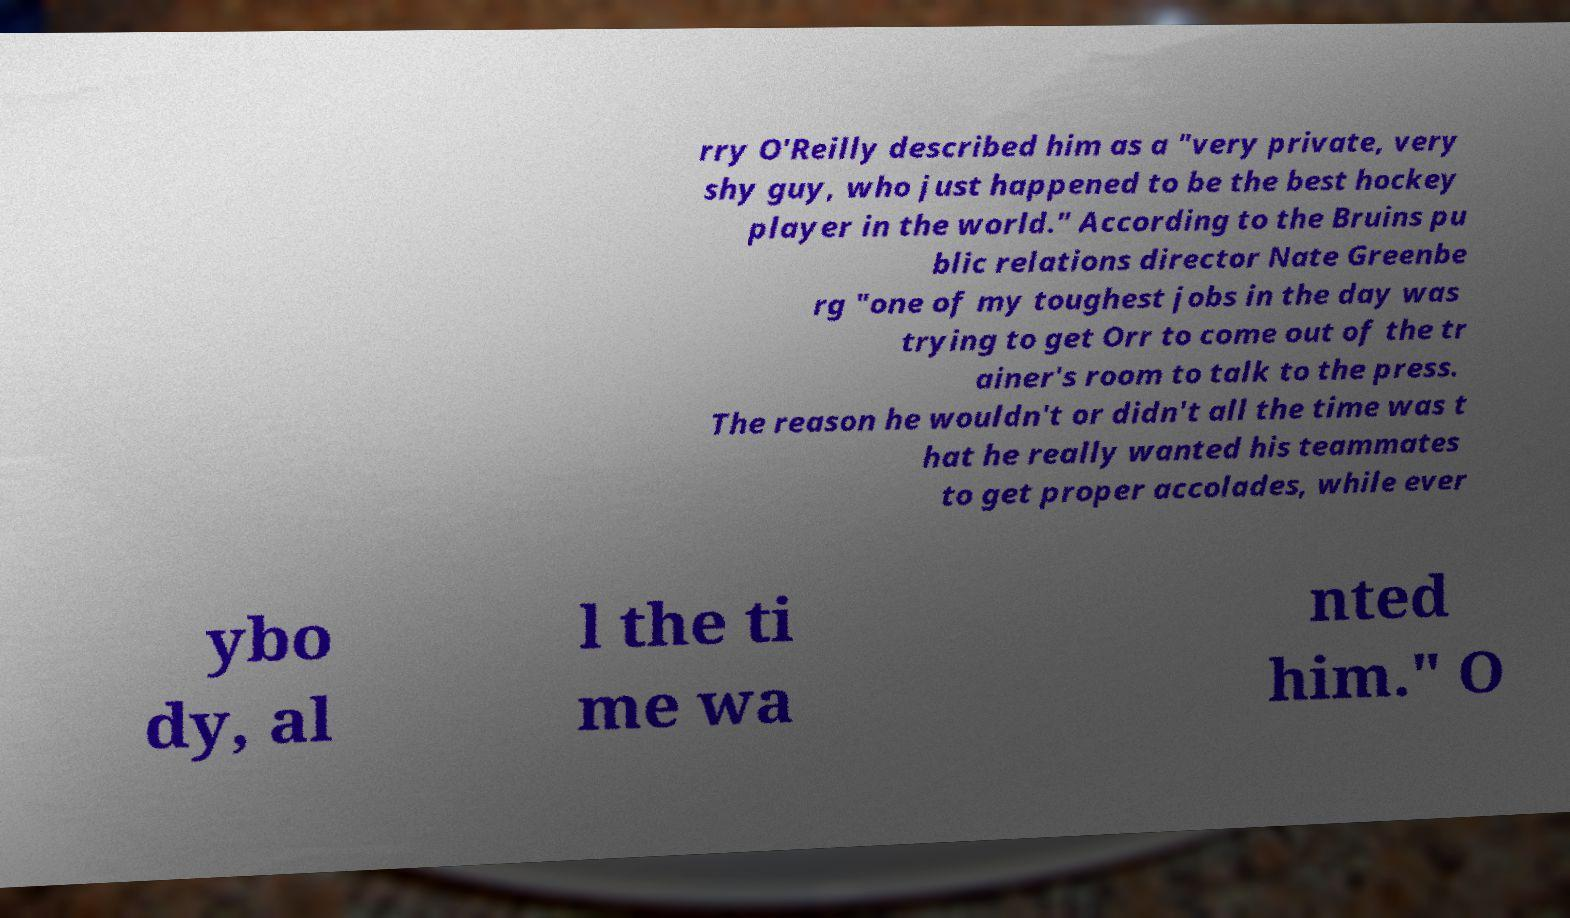Could you assist in decoding the text presented in this image and type it out clearly? rry O'Reilly described him as a "very private, very shy guy, who just happened to be the best hockey player in the world." According to the Bruins pu blic relations director Nate Greenbe rg "one of my toughest jobs in the day was trying to get Orr to come out of the tr ainer's room to talk to the press. The reason he wouldn't or didn't all the time was t hat he really wanted his teammates to get proper accolades, while ever ybo dy, al l the ti me wa nted him." O 